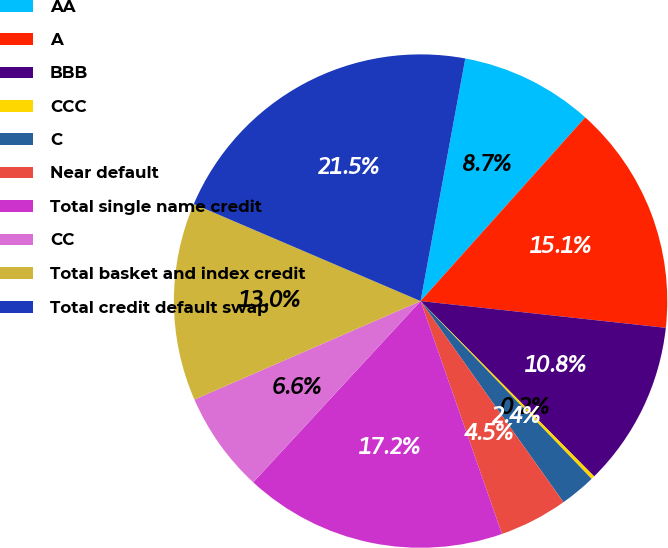<chart> <loc_0><loc_0><loc_500><loc_500><pie_chart><fcel>AA<fcel>A<fcel>BBB<fcel>CCC<fcel>C<fcel>Near default<fcel>Total single name credit<fcel>CC<fcel>Total basket and index credit<fcel>Total credit default swap<nl><fcel>8.73%<fcel>15.1%<fcel>10.85%<fcel>0.23%<fcel>2.36%<fcel>4.48%<fcel>17.22%<fcel>6.6%<fcel>12.97%<fcel>21.47%<nl></chart> 